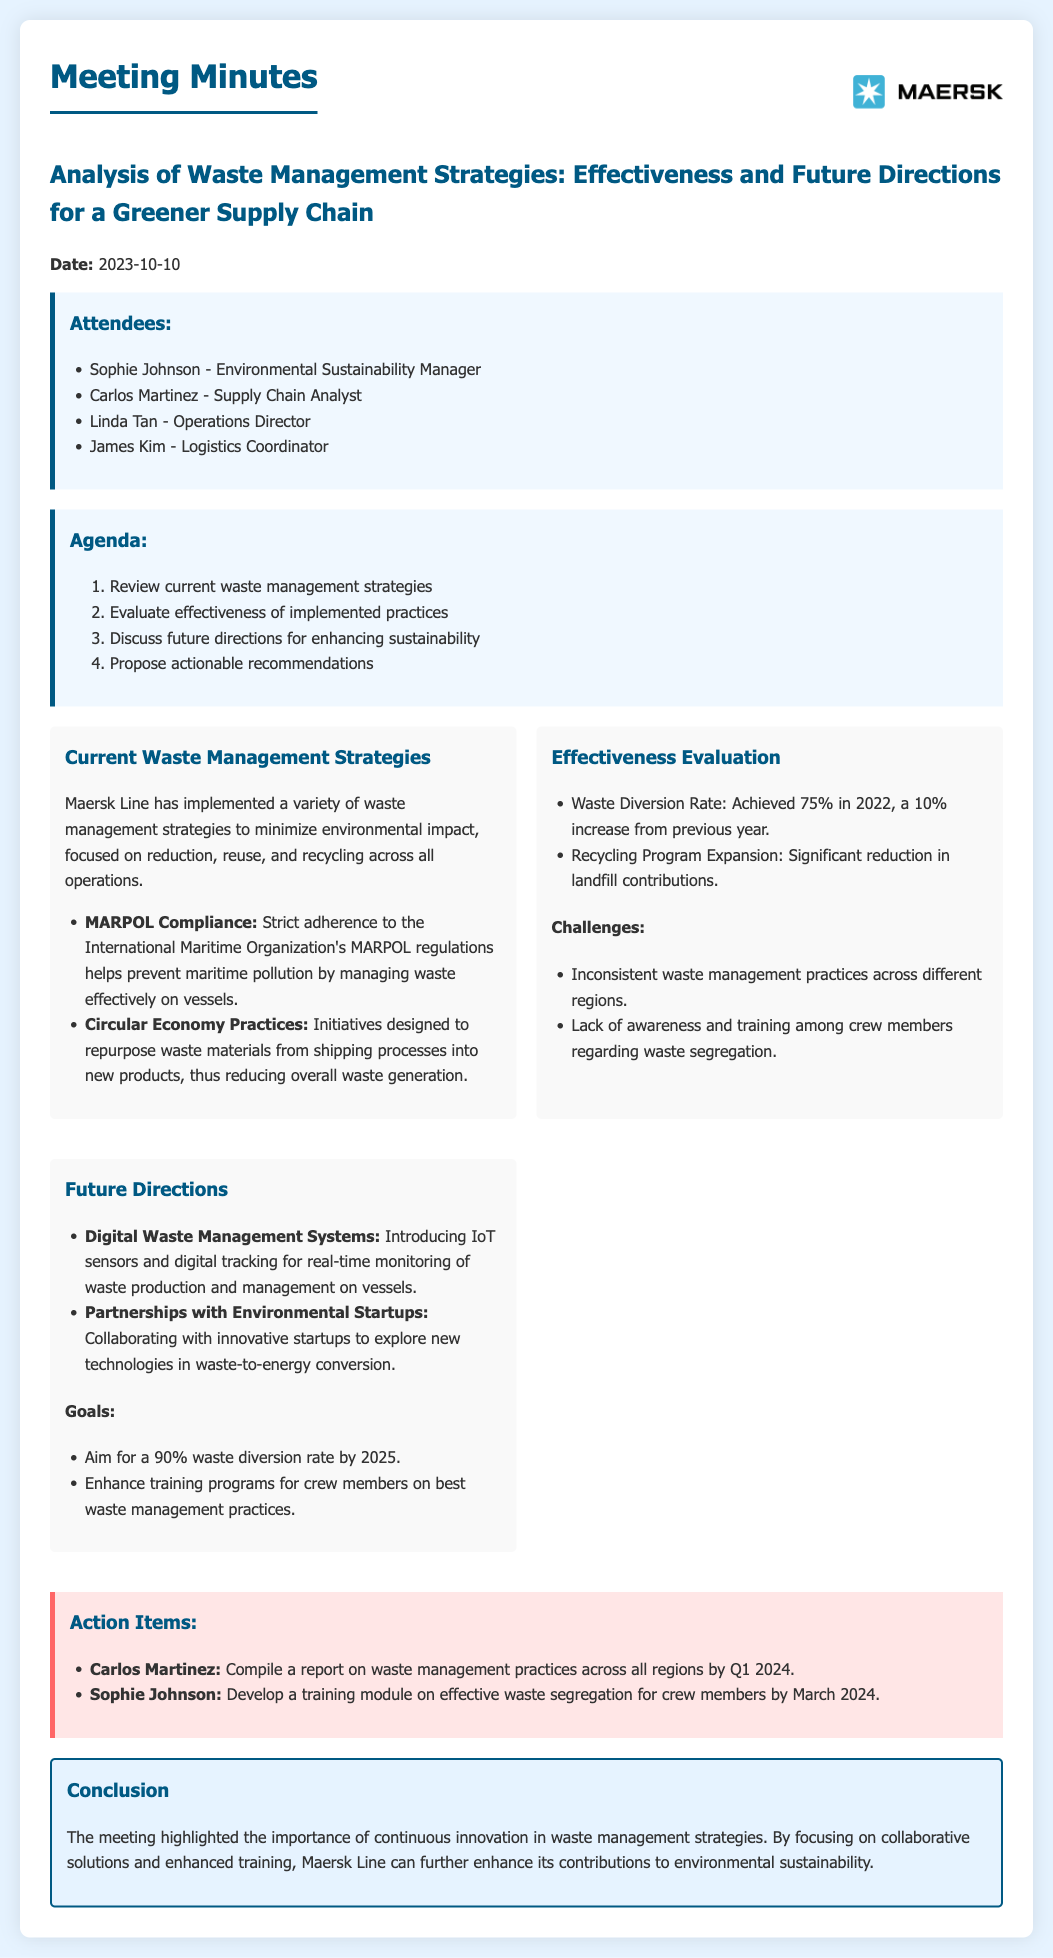What is the date of the meeting? The date of the meeting is stated at the beginning of the document.
Answer: 2023-10-10 Who is the Environmental Sustainability Manager? The document lists attendees and their roles.
Answer: Sophie Johnson What was the waste diversion rate achieved in 2022? The document specifies the waste diversion rate for 2022 as part of the effectiveness evaluation.
Answer: 75% What challenges were faced in waste management? The document outlines challenges in the effectiveness evaluation section.
Answer: Inconsistent waste management practices across different regions What is one future direction mentioned for waste management? The document lists future directions in a specific section.
Answer: Digital Waste Management Systems What is the goal for waste diversion by 2025? The document states a specific goal for waste management improvement.
Answer: 90% waste diversion rate Who is responsible for compiling a report on waste management practices? The action items section names individuals responsible for specific tasks.
Answer: Carlos Martinez When is the training module on effective waste segregation due? The document specifies a deadline for the training module in the action items.
Answer: March 2024 